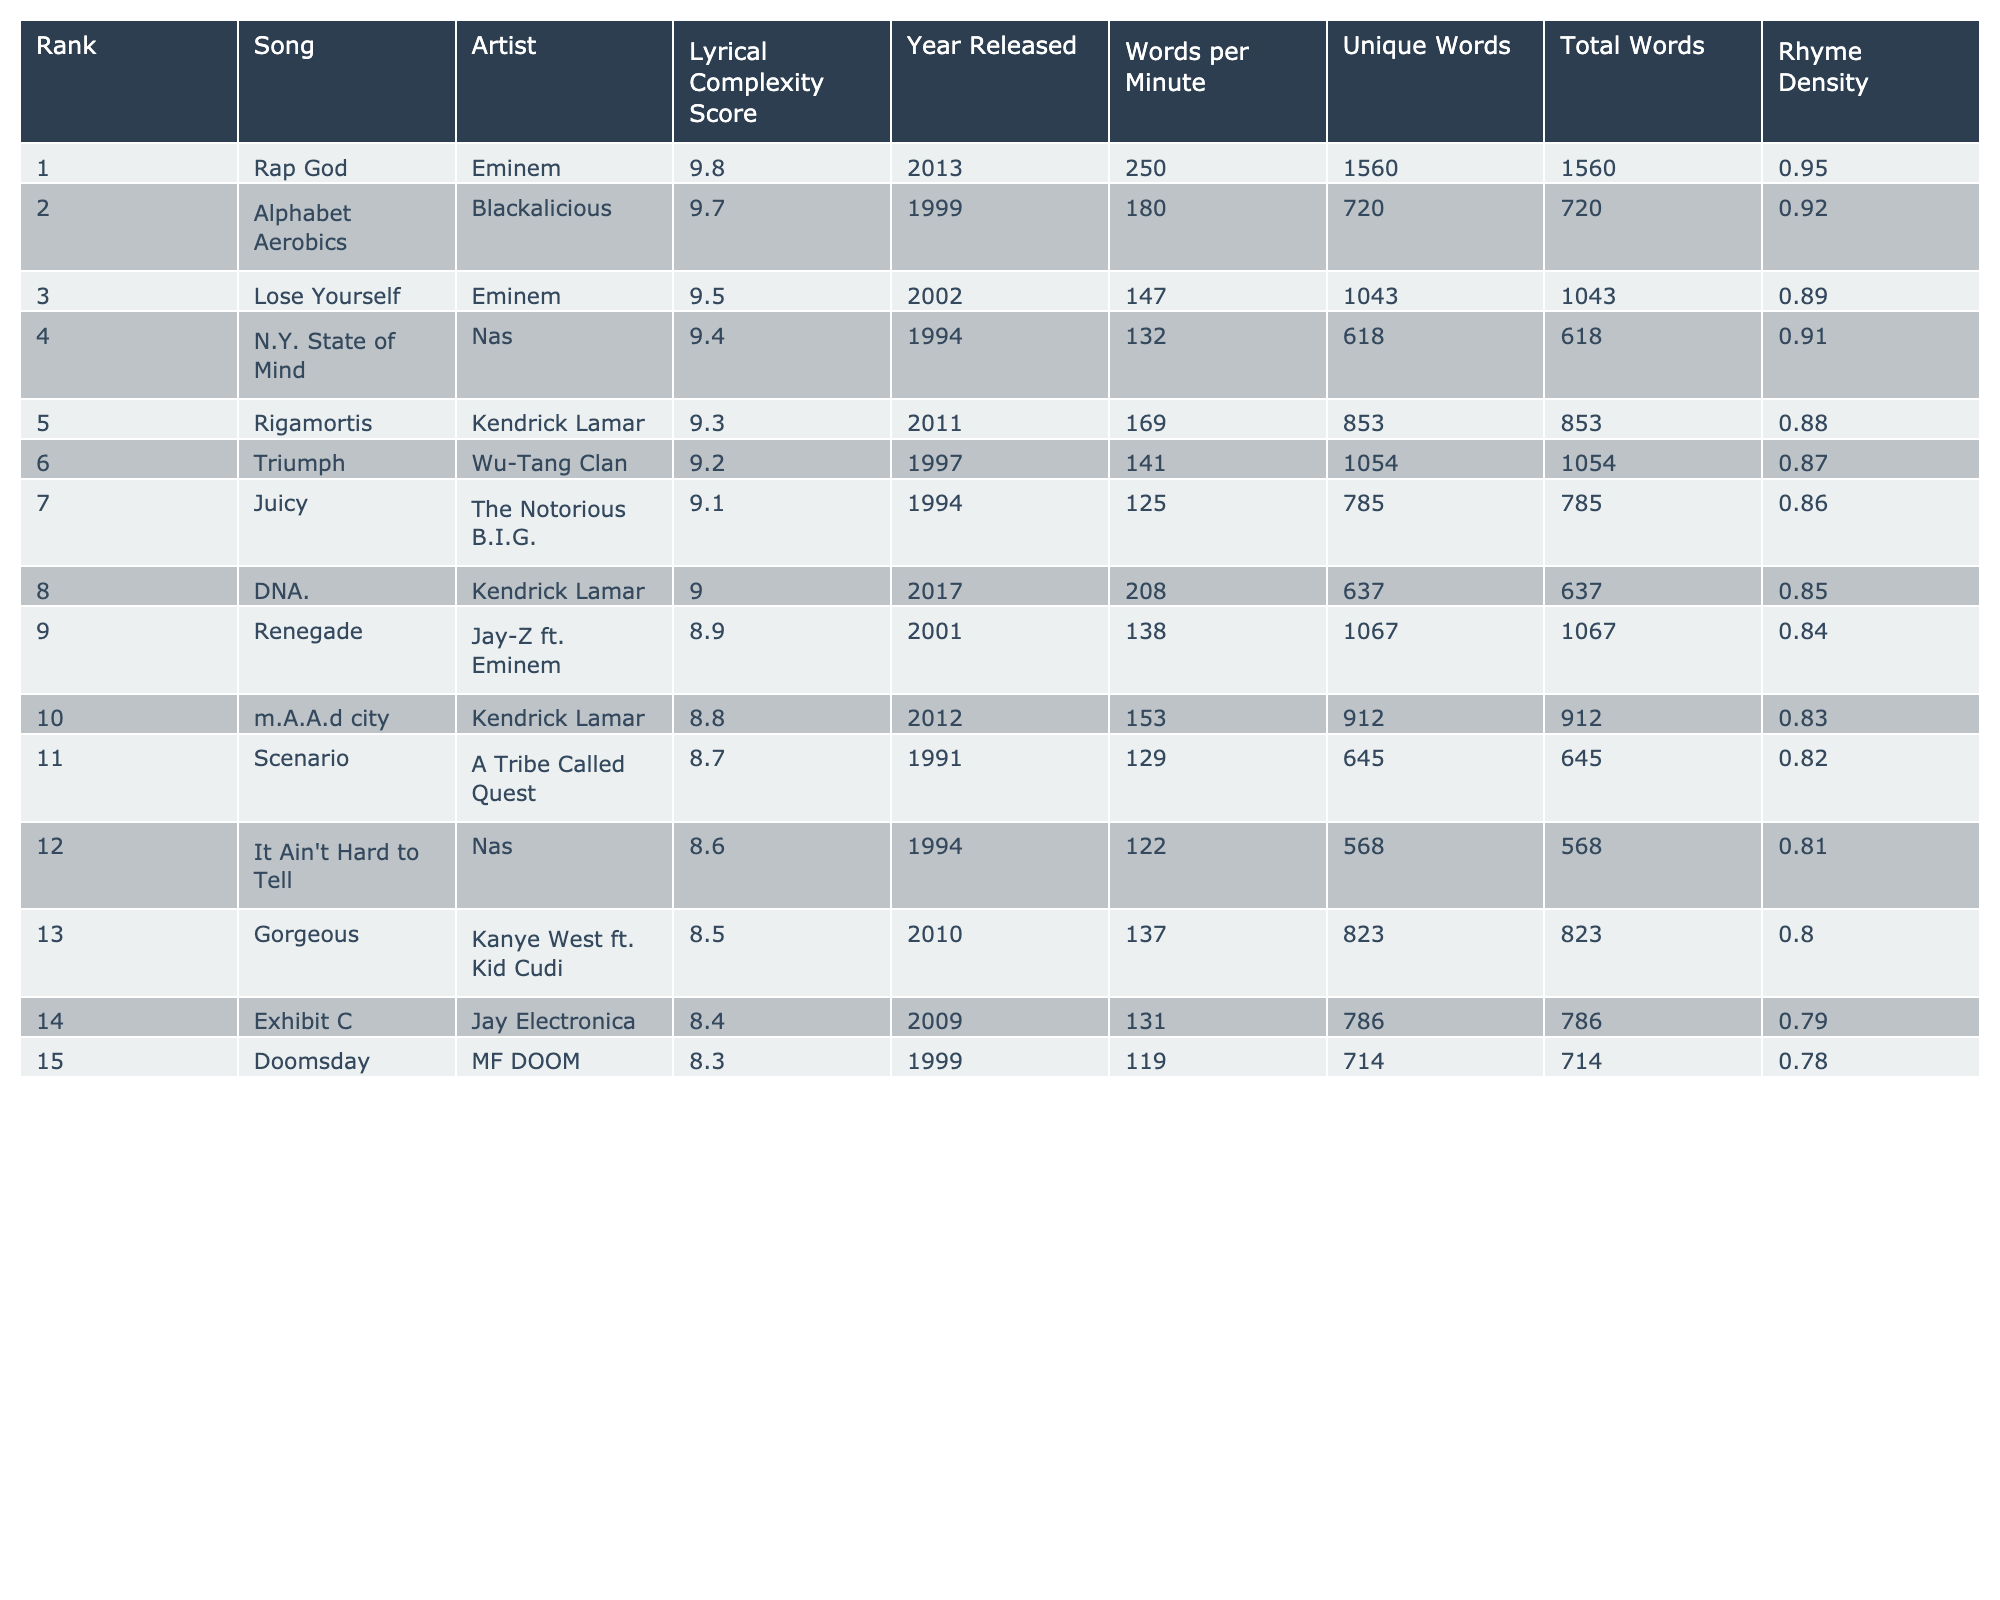What is the highest lyrical complexity score in the table? The table lists the lyrical complexity scores, and the highest score is found in the first row, which is 9.8 for the song "Rap God" by Eminem.
Answer: 9.8 Which artist has the most songs featured in the top 10? By examining the table, Eminem is featured in two songs: "Rap God" and "Lose Yourself," while Kendrick Lamar has two songs: "Rigamortis" and "DNA." The others have only one song each. Therefore, Eminem and Kendrick Lamar are tied for the most songs in the top 10.
Answer: Eminem and Kendrick Lamar How many unique words are used in "Triumph" by Wu-Tang Clan? Looking at the table, the song "Triumph" has 1054 total words and 141 unique words listed in its respective row.
Answer: 141 What is the average lyrical complexity score for the top 5 songs? To find the average, we add the scores of the top 5 songs: 9.8 + 9.7 + 9.5 + 9.4 + 9.3 = 47.7. Then divide by 5, which gives us an average score of 47.7/5 = 9.54.
Answer: 9.54 Did any song in the table have a rhyme density of 0.90 or above? By reviewing the rhyme density column, we see that only "Rap God" has a rhyme density of 0.95, which is above 0.90.
Answer: Yes Which song released in 2017 has the lowest rhyme density? The song in 2017 is "DNA." by Kendrick Lamar, which has a rhyme density of 0.85. This is the only song from that year in the table, making it the lowest by default.
Answer: DNA What is the difference between the lyrical complexity scores of "Lose Yourself" and "Juicy"? The score for "Lose Yourself" is 9.5, and for "Juicy," it's 9.1. The difference is 9.5 - 9.1 = 0.4.
Answer: 0.4 Which year had the highest average words per minute for songs in the top 10? We calculate the average words per minute for the top 10 songs. The values are 250, 180, 147, 132, 169, 141, 125, 208, 138, and 153, summing to 1,751 and dividing by 10 gives 175.1. This remains the highest average, as no other years are represented in the top 10.
Answer: 175.1 Is "N.Y. State of Mind" by Nas more lyrically complex than "It Ain't Hard to Tell"? "N.Y. State of Mind" has a score of 9.4 while "It Ain't Hard to Tell" has 8.6. Since 9.4 is higher than 8.6, "N.Y. State of Mind" is indeed more lyrically complex.
Answer: Yes What percentage of the total words in "Rigamortis" are unique? "Rigamortis" has 853 total words and 169 unique words. To find the percentage of unique words, we perform (169 / 853) * 100, which equals approximately 19.8%.
Answer: 19.8% 